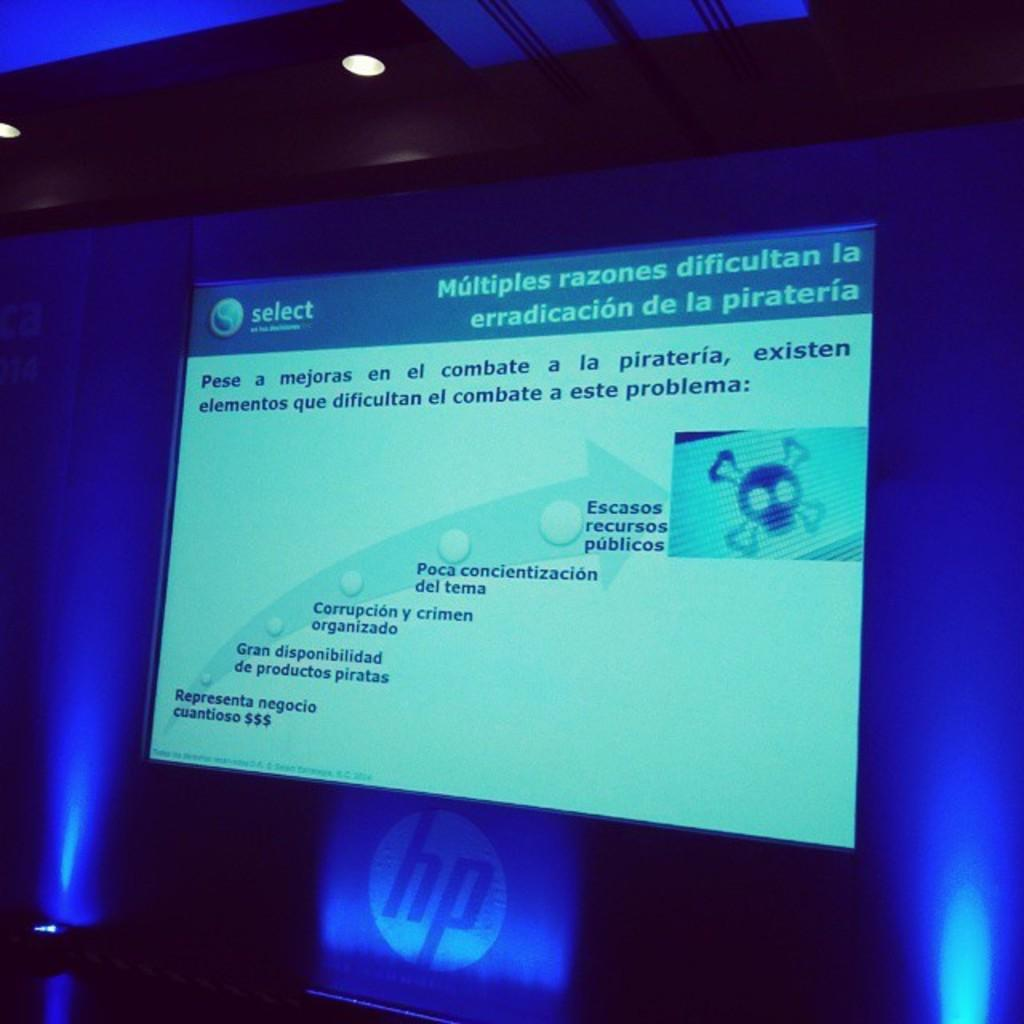<image>
Present a compact description of the photo's key features. The Spanish presentation is displayed on a HP computer. 